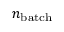Convert formula to latex. <formula><loc_0><loc_0><loc_500><loc_500>n _ { b a t c h }</formula> 